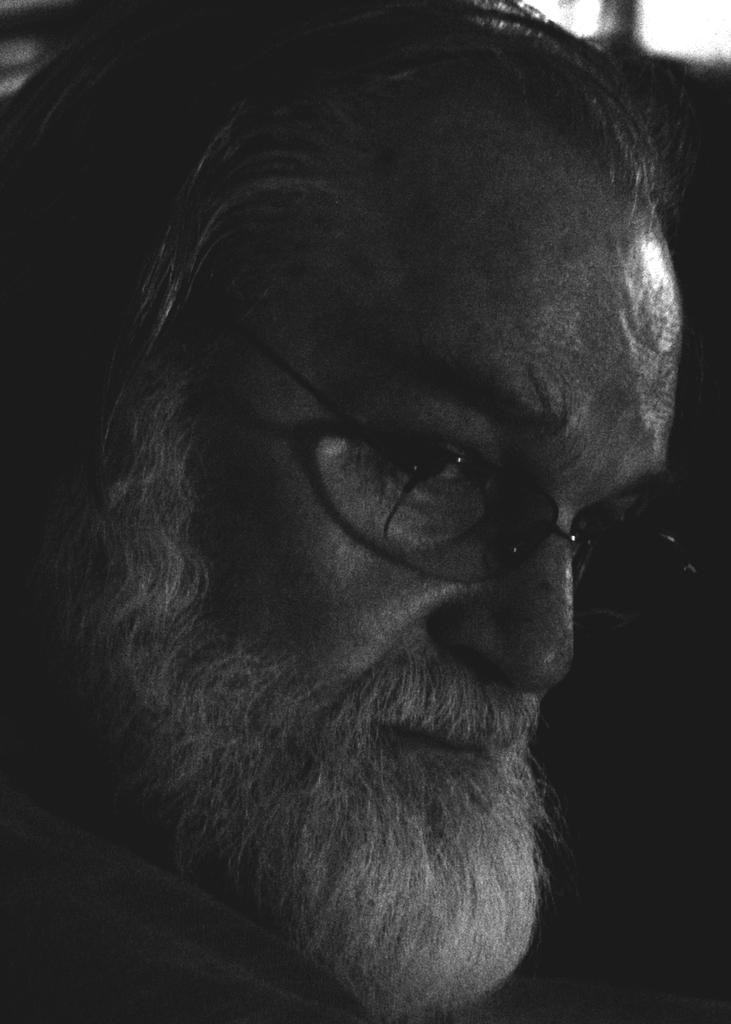What is the color scheme of the image? The image is black and white. What is the main subject of the image? There is a person's face in the image. What can be seen on the person's face? The person is wearing spectacles. What facial hair does the person have? The person has a beard and a mustache. Is there a fan attacking the person's face in the image? No, there is no fan or any form of attack present in the image. The image only shows a person's face with spectacles, a beard, and a mustache. 